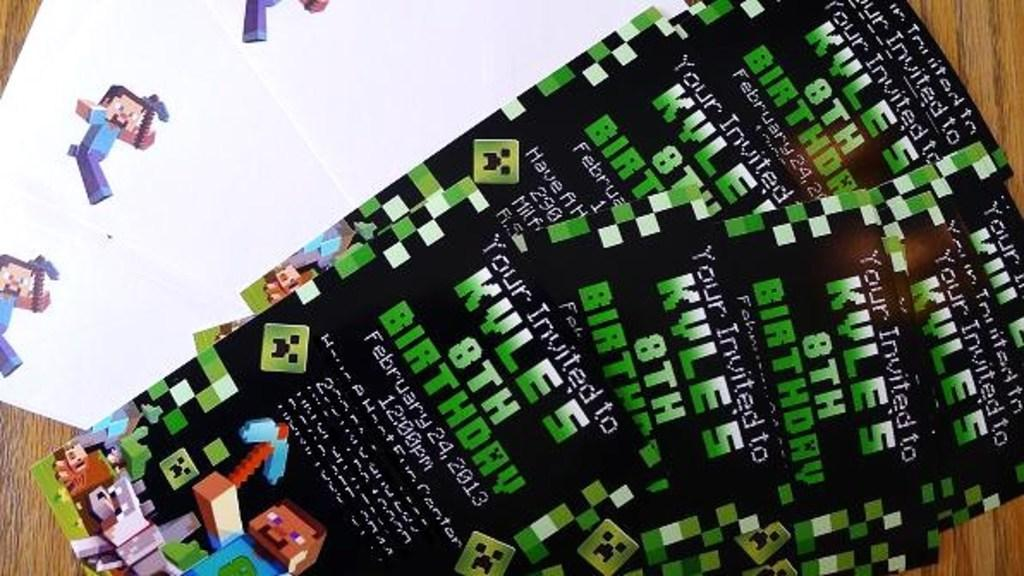What type of items can be seen on the table in the image? There are invitation cards and a paper on the table in the image. What is written or printed on the invitation cards? The invitation cards have text on them. Is there any visual element on the cards or paper? Yes, there is a cartoon picture on the cards or paper. What type of rhythm can be heard in the image? There is no sound or music in the image, so it is not possible to determine any rhythm. 